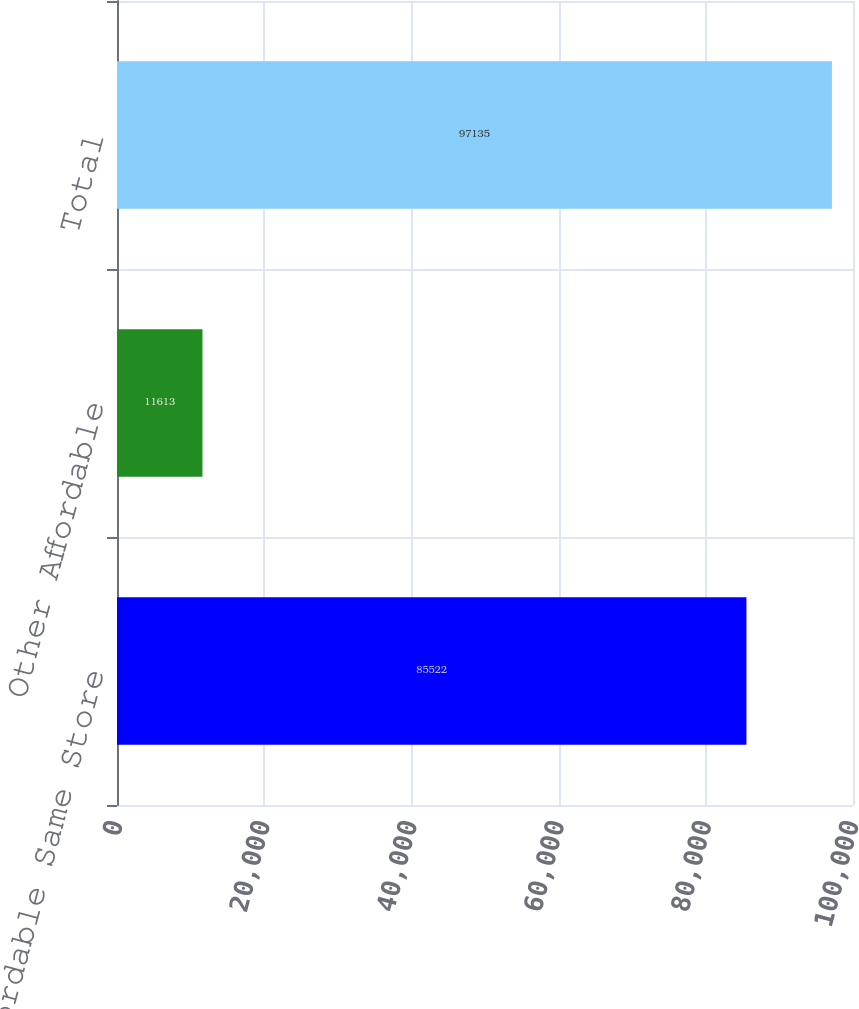Convert chart to OTSL. <chart><loc_0><loc_0><loc_500><loc_500><bar_chart><fcel>Affordable Same Store<fcel>Other Affordable<fcel>Total<nl><fcel>85522<fcel>11613<fcel>97135<nl></chart> 